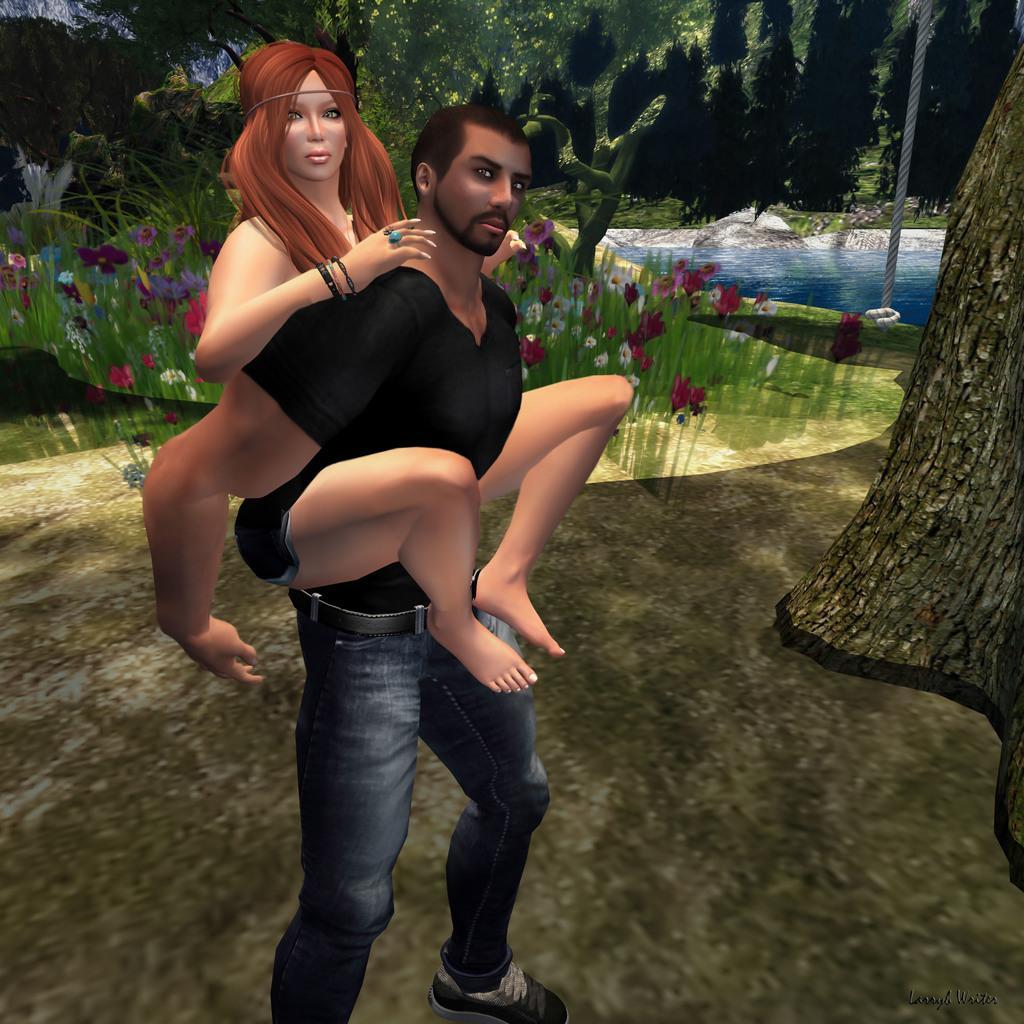How would you summarize this image in a sentence or two? In this picture I can see the animated image. In that image there is a man who is holding a woman. In the background I can see the mountain, river, flowers, plants and grass. On the right there is a pole. 